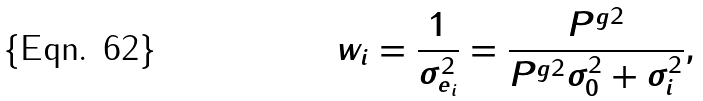Convert formula to latex. <formula><loc_0><loc_0><loc_500><loc_500>w _ { i } = \frac { 1 } { \sigma _ { e _ { i } } ^ { 2 } } = \frac { P ^ { g 2 } } { P ^ { g 2 } \sigma _ { 0 } ^ { 2 } + \sigma _ { i } ^ { 2 } } ,</formula> 